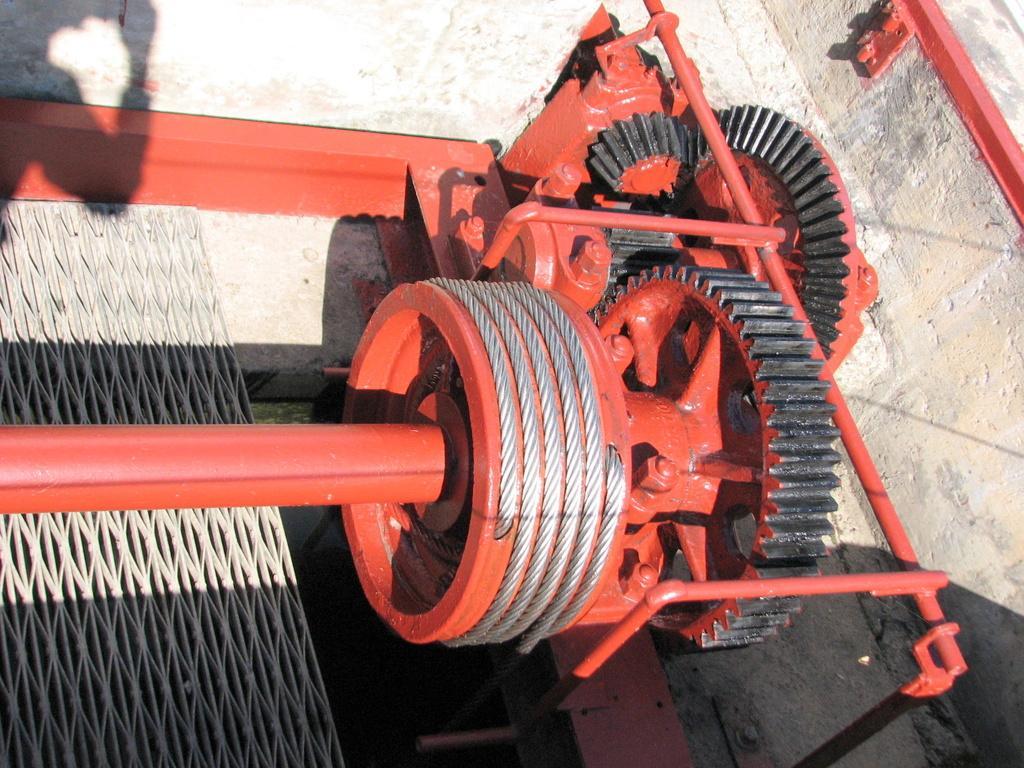How would you summarize this image in a sentence or two? In this picture we can see a machine and a mesh on the ground and in the background we can see the wall. 